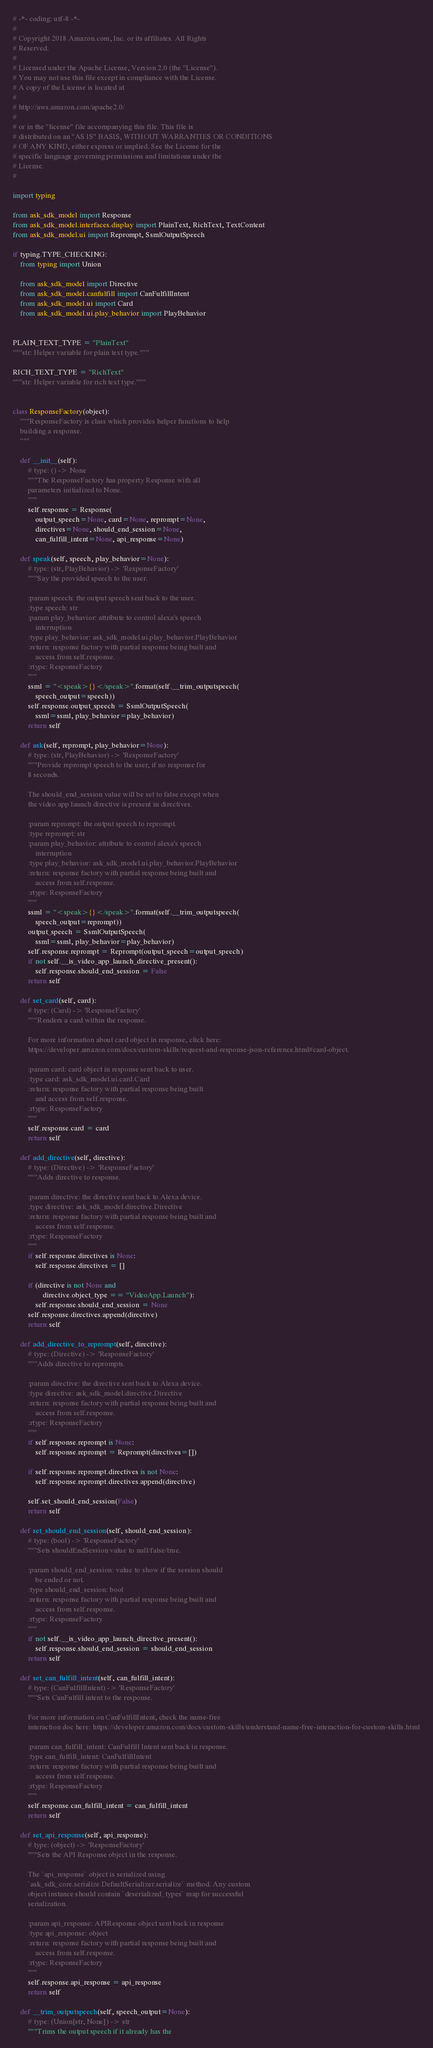<code> <loc_0><loc_0><loc_500><loc_500><_Python_># -*- coding: utf-8 -*-
#
# Copyright 2018 Amazon.com, Inc. or its affiliates. All Rights
# Reserved.
#
# Licensed under the Apache License, Version 2.0 (the "License").
# You may not use this file except in compliance with the License.
# A copy of the License is located at
#
# http://aws.amazon.com/apache2.0/
#
# or in the "license" file accompanying this file. This file is
# distributed on an "AS IS" BASIS, WITHOUT WARRANTIES OR CONDITIONS
# OF ANY KIND, either express or implied. See the License for the
# specific language governing permissions and limitations under the
# License.
#

import typing

from ask_sdk_model import Response
from ask_sdk_model.interfaces.display import PlainText, RichText, TextContent
from ask_sdk_model.ui import Reprompt, SsmlOutputSpeech

if typing.TYPE_CHECKING:
    from typing import Union

    from ask_sdk_model import Directive
    from ask_sdk_model.canfulfill import CanFulfillIntent
    from ask_sdk_model.ui import Card
    from ask_sdk_model.ui.play_behavior import PlayBehavior


PLAIN_TEXT_TYPE = "PlainText"
"""str: Helper variable for plain text type."""

RICH_TEXT_TYPE = "RichText"
"""str: Helper variable for rich text type."""


class ResponseFactory(object):
    """ResponseFactory is class which provides helper functions to help
    building a response.
    """

    def __init__(self):
        # type: () -> None
        """The ResponseFactory has property Response with all
        parameters initialized to None.
        """
        self.response = Response(
            output_speech=None, card=None, reprompt=None,
            directives=None, should_end_session=None,
            can_fulfill_intent=None, api_response=None)

    def speak(self, speech, play_behavior=None):
        # type: (str, PlayBehavior) -> 'ResponseFactory'
        """Say the provided speech to the user.

        :param speech: the output speech sent back to the user.
        :type speech: str
        :param play_behavior: attribute to control alexa's speech
            interruption
        :type play_behavior: ask_sdk_model.ui.play_behavior.PlayBehavior
        :return: response factory with partial response being built and
            access from self.response.
        :rtype: ResponseFactory
        """
        ssml = "<speak>{}</speak>".format(self.__trim_outputspeech(
            speech_output=speech))
        self.response.output_speech = SsmlOutputSpeech(
            ssml=ssml, play_behavior=play_behavior)
        return self

    def ask(self, reprompt, play_behavior=None):
        # type: (str, PlayBehavior) -> 'ResponseFactory'
        """Provide reprompt speech to the user, if no response for
        8 seconds.

        The should_end_session value will be set to false except when
        the video app launch directive is present in directives.

        :param reprompt: the output speech to reprompt.
        :type reprompt: str
        :param play_behavior: attribute to control alexa's speech
            interruption
        :type play_behavior: ask_sdk_model.ui.play_behavior.PlayBehavior
        :return: response factory with partial response being built and
            access from self.response.
        :rtype: ResponseFactory
        """
        ssml = "<speak>{}</speak>".format(self.__trim_outputspeech(
            speech_output=reprompt))
        output_speech = SsmlOutputSpeech(
            ssml=ssml, play_behavior=play_behavior)
        self.response.reprompt = Reprompt(output_speech=output_speech)
        if not self.__is_video_app_launch_directive_present():
            self.response.should_end_session = False
        return self

    def set_card(self, card):
        # type: (Card) -> 'ResponseFactory'
        """Renders a card within the response.

        For more information about card object in response, click here:
        https://developer.amazon.com/docs/custom-skills/request-and-response-json-reference.html#card-object.

        :param card: card object in response sent back to user.
        :type card: ask_sdk_model.ui.card.Card
        :return: response factory with partial response being built
            and access from self.response.
        :rtype: ResponseFactory
        """
        self.response.card = card
        return self

    def add_directive(self, directive):
        # type: (Directive) -> 'ResponseFactory'
        """Adds directive to response.

        :param directive: the directive sent back to Alexa device.
        :type directive: ask_sdk_model.directive.Directive
        :return: response factory with partial response being built and
            access from self.response.
        :rtype: ResponseFactory
        """
        if self.response.directives is None:
            self.response.directives = []

        if (directive is not None and
                directive.object_type == "VideoApp.Launch"):
            self.response.should_end_session = None
        self.response.directives.append(directive)
        return self

    def add_directive_to_reprompt(self, directive):
        # type: (Directive) -> 'ResponseFactory'
        """Adds directive to reprompts.

        :param directive: the directive sent back to Alexa device.
        :type directive: ask_sdk_model.directive.Directive
        :return: response factory with partial response being built and
            access from self.response.
        :rtype: ResponseFactory
        """
        if self.response.reprompt is None:
            self.response.reprompt = Reprompt(directives=[])

        if self.response.reprompt.directives is not None:
            self.response.reprompt.directives.append(directive)

        self.set_should_end_session(False)
        return self

    def set_should_end_session(self, should_end_session):
        # type: (bool) -> 'ResponseFactory'
        """Sets shouldEndSession value to null/false/true.

        :param should_end_session: value to show if the session should
            be ended or not.
        :type should_end_session: bool
        :return: response factory with partial response being built and
            access from self.response.
        :rtype: ResponseFactory
        """
        if not self.__is_video_app_launch_directive_present():
            self.response.should_end_session = should_end_session
        return self

    def set_can_fulfill_intent(self, can_fulfill_intent):
        # type: (CanFulfillIntent) -> 'ResponseFactory'
        """Sets CanFulfill intent to the response.

        For more information on CanFulfillIntent, check the name-free
        interaction doc here: https://developer.amazon.com/docs/custom-skills/understand-name-free-interaction-for-custom-skills.html

        :param can_fulfill_intent: CanFulfill Intent sent back in response.
        :type can_fulfill_intent: CanFulfillIntent
        :return: response factory with partial response being built and
            access from self.response.
        :rtype: ResponseFactory
        """
        self.response.can_fulfill_intent = can_fulfill_intent
        return self

    def set_api_response(self, api_response):
        # type: (object) -> 'ResponseFactory'
        """Sets the API Response object in the response.

        The `api_response` object is serialized using
        `ask_sdk_core.serialize.DefaultSerializer.serialize` method. Any custom
        object instance should contain `deserialized_types` map for successful
        serialization.

        :param api_response: APIResponse object sent back in response
        :type api_response: object
        :return: response factory with partial response being built and
            access from self.response.
        :rtype: ResponseFactory
        """
        self.response.api_response = api_response
        return self

    def __trim_outputspeech(self, speech_output=None):
        # type: (Union[str, None]) -> str
        """Trims the output speech if it already has the</code> 